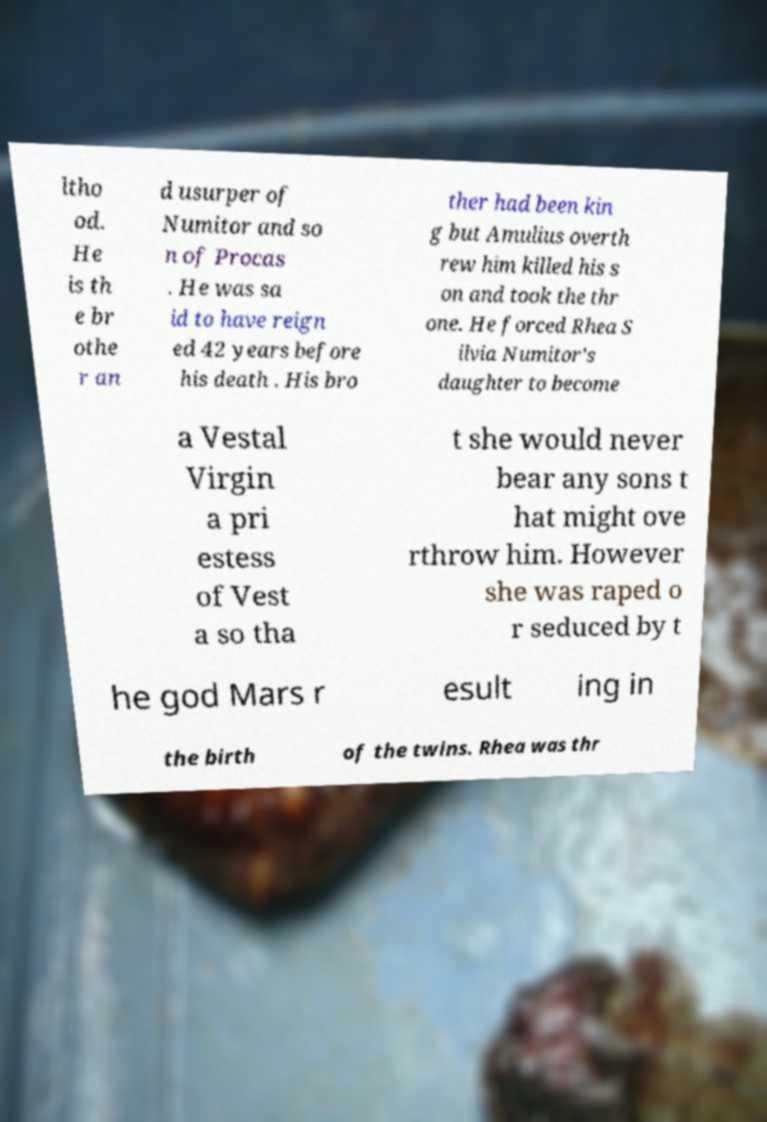What messages or text are displayed in this image? I need them in a readable, typed format. ltho od. He is th e br othe r an d usurper of Numitor and so n of Procas . He was sa id to have reign ed 42 years before his death . His bro ther had been kin g but Amulius overth rew him killed his s on and took the thr one. He forced Rhea S ilvia Numitor's daughter to become a Vestal Virgin a pri estess of Vest a so tha t she would never bear any sons t hat might ove rthrow him. However she was raped o r seduced by t he god Mars r esult ing in the birth of the twins. Rhea was thr 